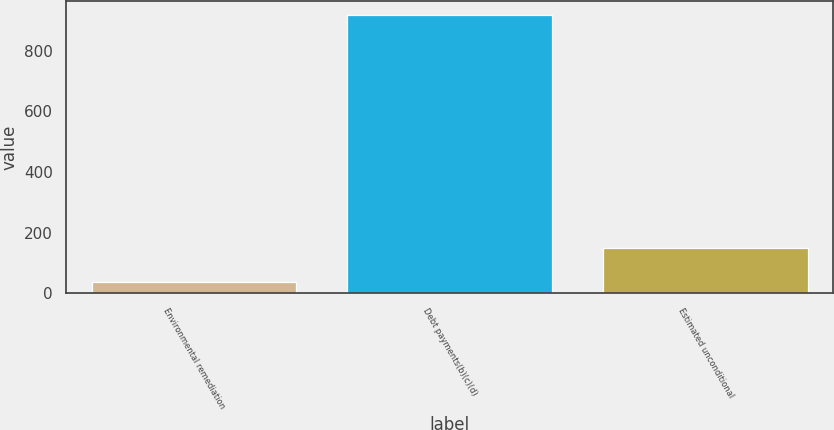<chart> <loc_0><loc_0><loc_500><loc_500><bar_chart><fcel>Environmental remediation<fcel>Debt payments(b)(c)(d)<fcel>Estimated unconditional<nl><fcel>38<fcel>918<fcel>148<nl></chart> 